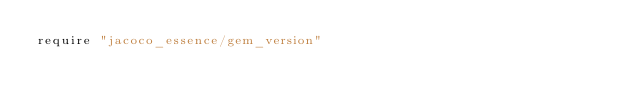Convert code to text. <code><loc_0><loc_0><loc_500><loc_500><_Ruby_>require "jacoco_essence/gem_version"
</code> 